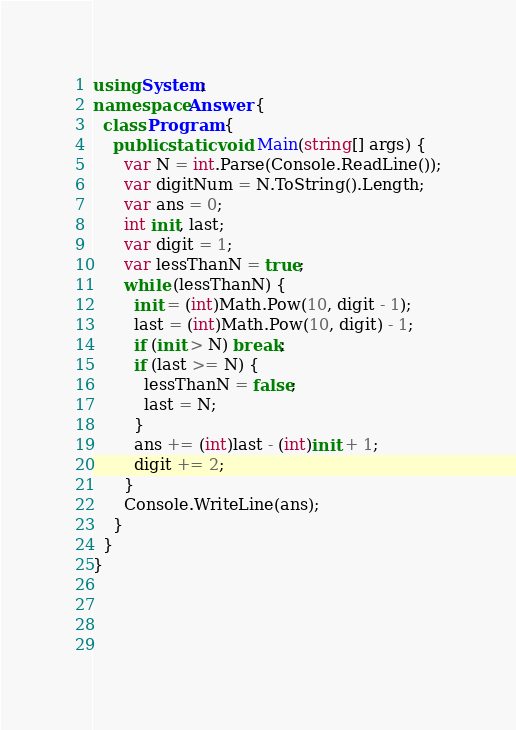Convert code to text. <code><loc_0><loc_0><loc_500><loc_500><_C#_>using System;
namespace Answer {
  class Program {
    public static void Main(string[] args) {
      var N = int.Parse(Console.ReadLine());
      var digitNum = N.ToString().Length;
      var ans = 0;
      int init, last;
      var digit = 1;
      var lessThanN = true;
      while (lessThanN) {
        init = (int)Math.Pow(10, digit - 1);
        last = (int)Math.Pow(10, digit) - 1;
        if (init > N) break;
        if (last >= N) {
          lessThanN = false;
          last = N;
        }
        ans += (int)last - (int)init + 1;
        digit += 2;
      }
      Console.WriteLine(ans);
    }
  }
}
        
        
        
      
</code> 